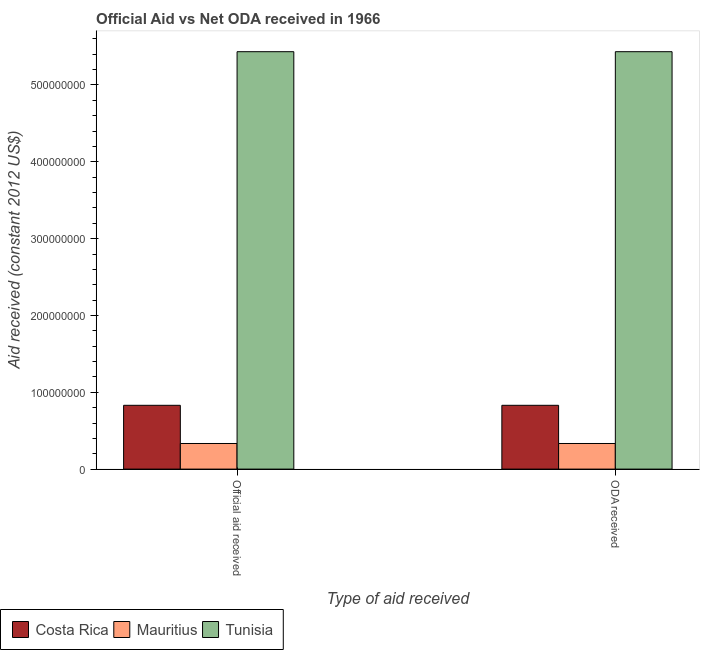How many different coloured bars are there?
Your answer should be compact. 3. Are the number of bars on each tick of the X-axis equal?
Ensure brevity in your answer.  Yes. How many bars are there on the 1st tick from the right?
Your answer should be very brief. 3. What is the label of the 1st group of bars from the left?
Make the answer very short. Official aid received. What is the official aid received in Mauritius?
Provide a succinct answer. 3.33e+07. Across all countries, what is the maximum official aid received?
Your answer should be compact. 5.43e+08. Across all countries, what is the minimum oda received?
Keep it short and to the point. 3.33e+07. In which country was the oda received maximum?
Your response must be concise. Tunisia. In which country was the official aid received minimum?
Provide a short and direct response. Mauritius. What is the total oda received in the graph?
Your answer should be very brief. 6.60e+08. What is the difference between the oda received in Costa Rica and that in Mauritius?
Keep it short and to the point. 4.97e+07. What is the difference between the official aid received in Mauritius and the oda received in Tunisia?
Your response must be concise. -5.10e+08. What is the average oda received per country?
Provide a succinct answer. 2.20e+08. What is the ratio of the oda received in Tunisia to that in Costa Rica?
Ensure brevity in your answer.  6.54. Is the official aid received in Tunisia less than that in Costa Rica?
Your answer should be very brief. No. In how many countries, is the official aid received greater than the average official aid received taken over all countries?
Ensure brevity in your answer.  1. What does the 3rd bar from the left in Official aid received represents?
Give a very brief answer. Tunisia. What does the 1st bar from the right in ODA received represents?
Offer a terse response. Tunisia. Are all the bars in the graph horizontal?
Keep it short and to the point. No. Does the graph contain any zero values?
Your answer should be very brief. No. Does the graph contain grids?
Ensure brevity in your answer.  No. How many legend labels are there?
Give a very brief answer. 3. What is the title of the graph?
Offer a very short reply. Official Aid vs Net ODA received in 1966 . What is the label or title of the X-axis?
Make the answer very short. Type of aid received. What is the label or title of the Y-axis?
Make the answer very short. Aid received (constant 2012 US$). What is the Aid received (constant 2012 US$) in Costa Rica in Official aid received?
Give a very brief answer. 8.30e+07. What is the Aid received (constant 2012 US$) of Mauritius in Official aid received?
Keep it short and to the point. 3.33e+07. What is the Aid received (constant 2012 US$) in Tunisia in Official aid received?
Provide a succinct answer. 5.43e+08. What is the Aid received (constant 2012 US$) of Costa Rica in ODA received?
Give a very brief answer. 8.30e+07. What is the Aid received (constant 2012 US$) of Mauritius in ODA received?
Give a very brief answer. 3.33e+07. What is the Aid received (constant 2012 US$) in Tunisia in ODA received?
Make the answer very short. 5.43e+08. Across all Type of aid received, what is the maximum Aid received (constant 2012 US$) of Costa Rica?
Make the answer very short. 8.30e+07. Across all Type of aid received, what is the maximum Aid received (constant 2012 US$) of Mauritius?
Provide a short and direct response. 3.33e+07. Across all Type of aid received, what is the maximum Aid received (constant 2012 US$) of Tunisia?
Your response must be concise. 5.43e+08. Across all Type of aid received, what is the minimum Aid received (constant 2012 US$) in Costa Rica?
Your answer should be very brief. 8.30e+07. Across all Type of aid received, what is the minimum Aid received (constant 2012 US$) in Mauritius?
Make the answer very short. 3.33e+07. Across all Type of aid received, what is the minimum Aid received (constant 2012 US$) of Tunisia?
Provide a succinct answer. 5.43e+08. What is the total Aid received (constant 2012 US$) of Costa Rica in the graph?
Your response must be concise. 1.66e+08. What is the total Aid received (constant 2012 US$) of Mauritius in the graph?
Provide a succinct answer. 6.67e+07. What is the total Aid received (constant 2012 US$) in Tunisia in the graph?
Your answer should be compact. 1.09e+09. What is the difference between the Aid received (constant 2012 US$) in Costa Rica in Official aid received and that in ODA received?
Give a very brief answer. 0. What is the difference between the Aid received (constant 2012 US$) of Mauritius in Official aid received and that in ODA received?
Provide a succinct answer. 0. What is the difference between the Aid received (constant 2012 US$) in Costa Rica in Official aid received and the Aid received (constant 2012 US$) in Mauritius in ODA received?
Provide a succinct answer. 4.97e+07. What is the difference between the Aid received (constant 2012 US$) of Costa Rica in Official aid received and the Aid received (constant 2012 US$) of Tunisia in ODA received?
Keep it short and to the point. -4.60e+08. What is the difference between the Aid received (constant 2012 US$) in Mauritius in Official aid received and the Aid received (constant 2012 US$) in Tunisia in ODA received?
Offer a very short reply. -5.10e+08. What is the average Aid received (constant 2012 US$) in Costa Rica per Type of aid received?
Your answer should be compact. 8.30e+07. What is the average Aid received (constant 2012 US$) in Mauritius per Type of aid received?
Your answer should be compact. 3.33e+07. What is the average Aid received (constant 2012 US$) in Tunisia per Type of aid received?
Your answer should be compact. 5.43e+08. What is the difference between the Aid received (constant 2012 US$) in Costa Rica and Aid received (constant 2012 US$) in Mauritius in Official aid received?
Keep it short and to the point. 4.97e+07. What is the difference between the Aid received (constant 2012 US$) in Costa Rica and Aid received (constant 2012 US$) in Tunisia in Official aid received?
Ensure brevity in your answer.  -4.60e+08. What is the difference between the Aid received (constant 2012 US$) of Mauritius and Aid received (constant 2012 US$) of Tunisia in Official aid received?
Your answer should be very brief. -5.10e+08. What is the difference between the Aid received (constant 2012 US$) in Costa Rica and Aid received (constant 2012 US$) in Mauritius in ODA received?
Your answer should be very brief. 4.97e+07. What is the difference between the Aid received (constant 2012 US$) of Costa Rica and Aid received (constant 2012 US$) of Tunisia in ODA received?
Offer a terse response. -4.60e+08. What is the difference between the Aid received (constant 2012 US$) in Mauritius and Aid received (constant 2012 US$) in Tunisia in ODA received?
Ensure brevity in your answer.  -5.10e+08. What is the ratio of the Aid received (constant 2012 US$) of Mauritius in Official aid received to that in ODA received?
Ensure brevity in your answer.  1. What is the ratio of the Aid received (constant 2012 US$) of Tunisia in Official aid received to that in ODA received?
Offer a terse response. 1. What is the difference between the highest and the second highest Aid received (constant 2012 US$) of Costa Rica?
Offer a very short reply. 0. What is the difference between the highest and the second highest Aid received (constant 2012 US$) of Mauritius?
Provide a short and direct response. 0. What is the difference between the highest and the second highest Aid received (constant 2012 US$) of Tunisia?
Provide a short and direct response. 0. What is the difference between the highest and the lowest Aid received (constant 2012 US$) of Costa Rica?
Offer a terse response. 0. What is the difference between the highest and the lowest Aid received (constant 2012 US$) in Tunisia?
Your response must be concise. 0. 